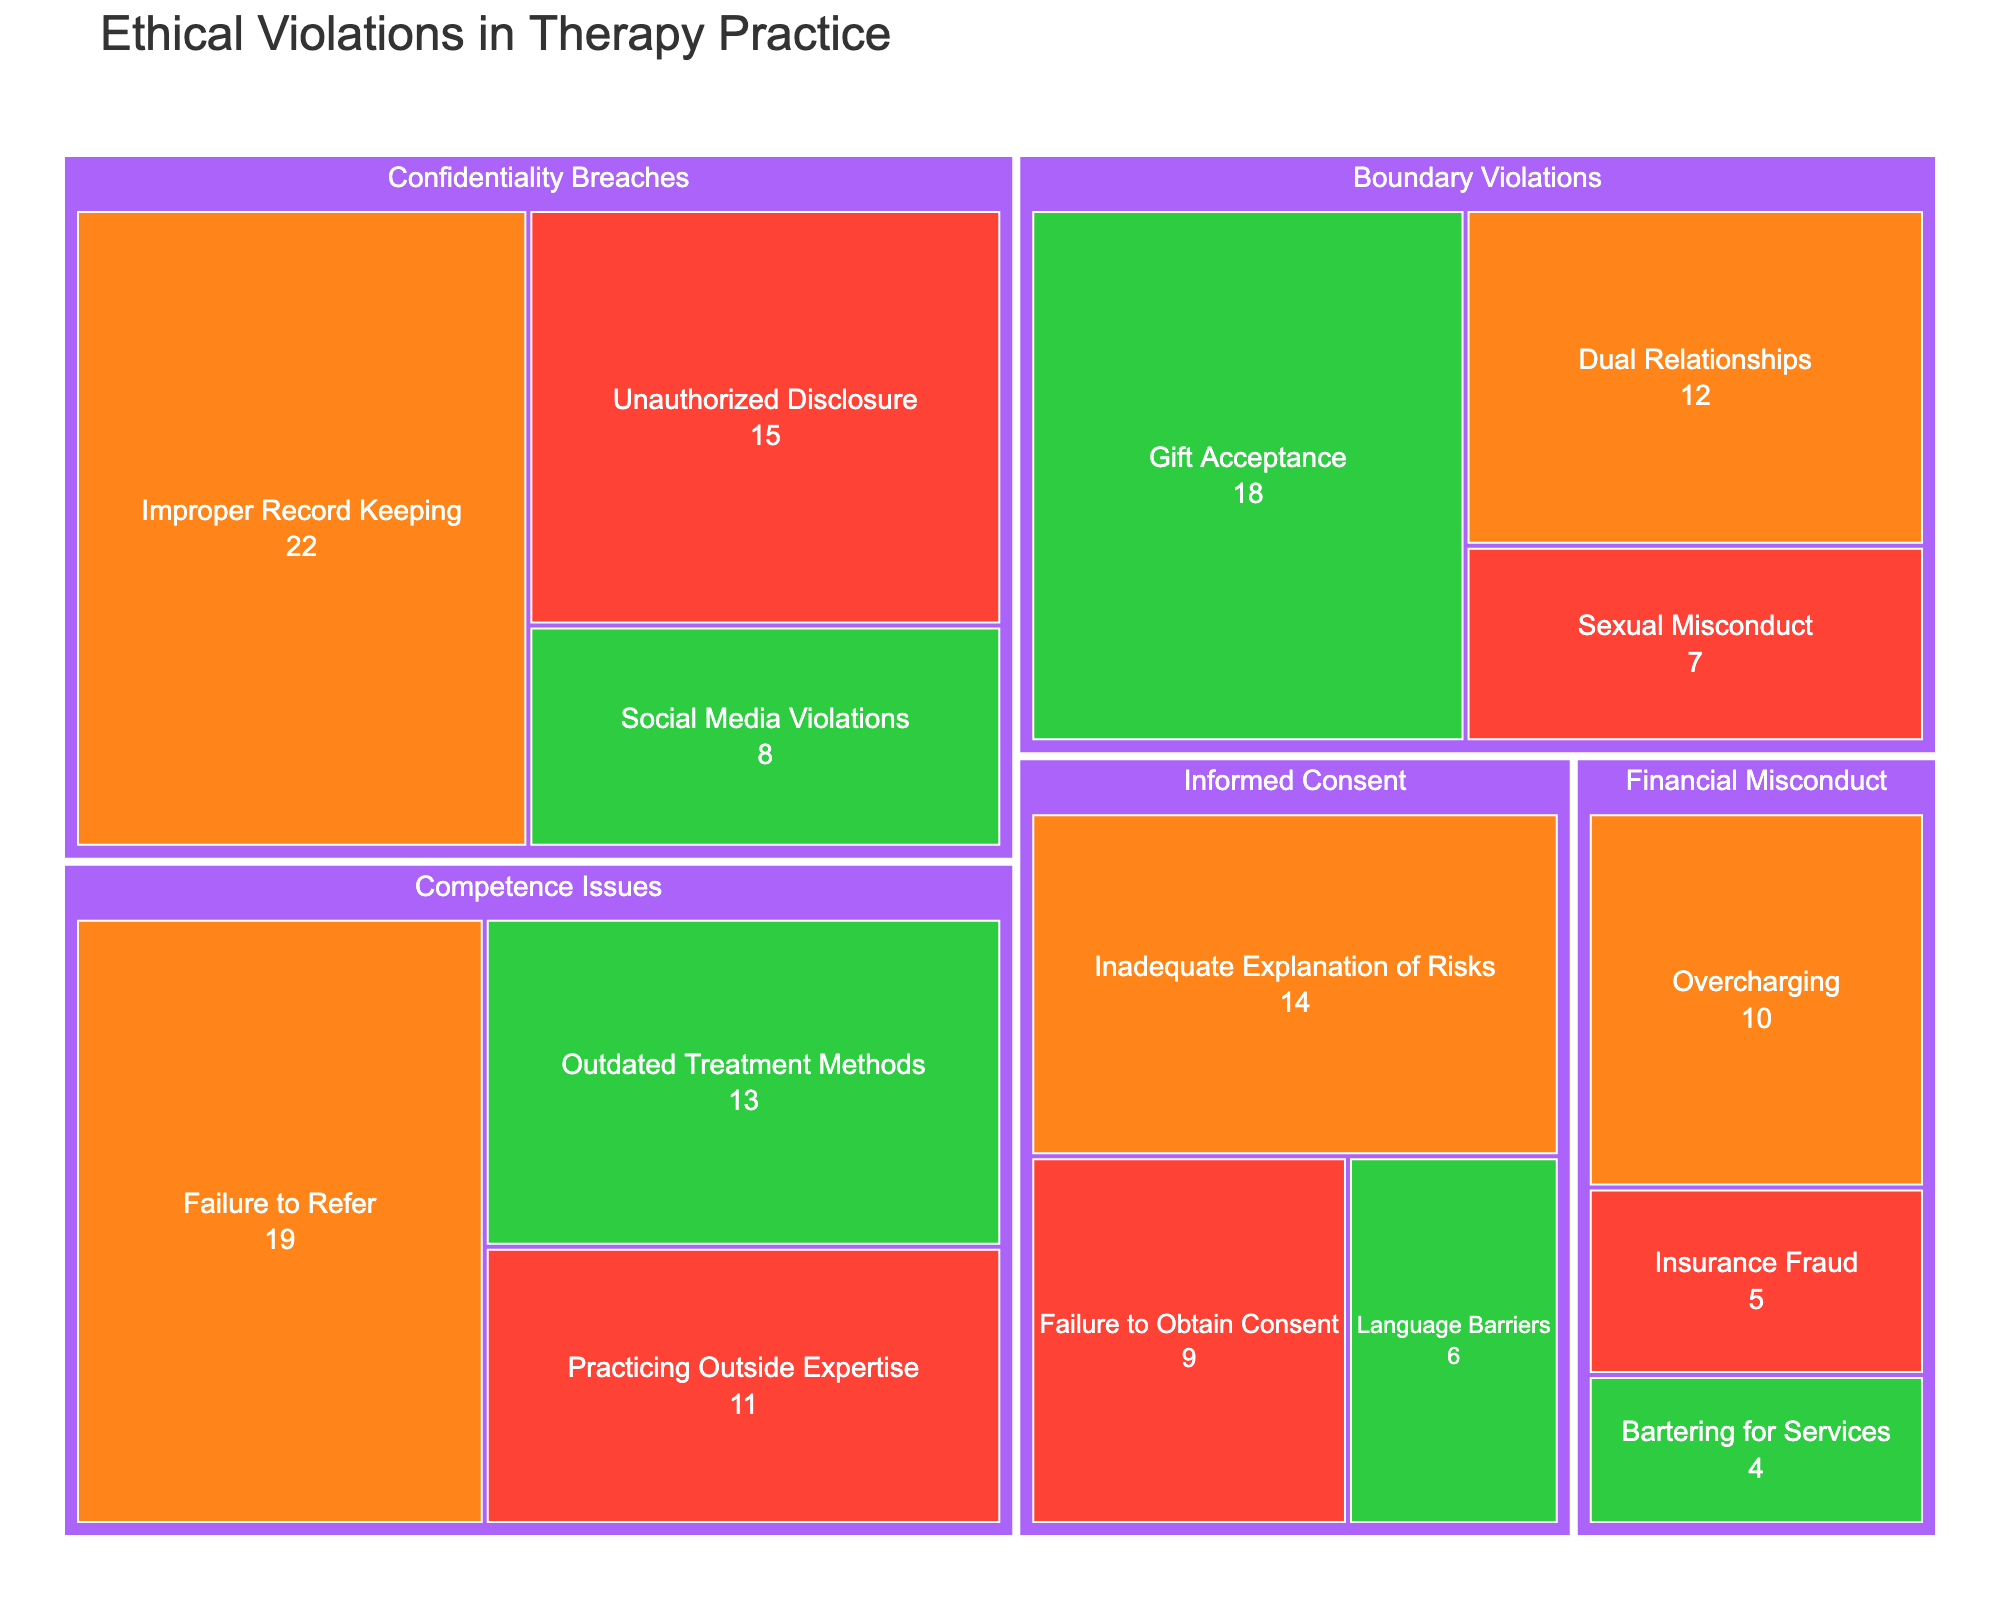What is the title of the figure? The title of the figure is usually prominently displayed at the top of the chart.
Answer: Ethical Violations in Therapy Practice Which subcategory under Boundary Violations has the highest frequency? By looking at the segments under "Boundary Violations," find the one with the largest area or highest value. This is "Gift Acceptance."
Answer: Gift Acceptance How many subcategories are under the Confidentiality Breaches category, and what are they? Count the subcategories within the "Confidentiality Breaches" section: "Unauthorized Disclosure," "Improper Record Keeping," and "Social Media Violations."
Answer: Three: Unauthorized Disclosure, Improper Record Keeping, Social Media Violations Compare the severity and frequency of dual relationships and gift acceptance violations. Which one is more frequent? Both "Dual Relationships" and "Gift Acceptance" are under "Boundary Violations." By comparing them, "Gift Acceptance" has a higher frequency (18) but a lower severity (Low).
Answer: Gift Acceptance What is the total frequency of all high-severity ethical violations? Sum the frequencies of all segments labeled as high severity: 15 (Unauthorized Disclosure) + 7 (Sexual Misconduct) + 9 (Failure to Obtain Consent) + 11 (Practicing Outside Expertise) + 5 (Insurance Fraud) = 47.
Answer: 47 Which category has the highest overall frequency and what is it? Sum the frequencies within each category and find the maximum value: Confidentiality Breaches (15+22+8), Boundary Violations (7+12+18), Informed Consent (9+14+6), Competence Issues (11+19+13), and Financial Misconduct (5+10+4). The highest is "Confidentiality Breaches" with a total of 45.
Answer: Confidentiality Breaches with 45 What is the severity of "Overcharging" in the category of Financial Misconduct? Locate the "Financial Misconduct" section and find the subcategory "Overcharging;" its severity is labeled "Medium."
Answer: Medium Between "Informed Consent" and "Competence Issues," which category has the least severe violations overall, considering both frequency and severity? Compare subcategories in "Informed Consent" and "Competence Issues" and note the severity and frequencies: "Informed Consent" has 9 (High), 14 (Medium), 6 (Low) resulting in 29 with varying severities; "Competence Issues" has 11 (High), 19 (Medium), 13 (Low) totaling 43 with varying severities. "Informed Consent" is less severe overall due to lower frequencies and mixed severities.
Answer: Informed Consent What is the most common severity of ethical violations depicted in the treemap? Count frequencies of high, medium, and low severity segments and compare: High (15+7+9+11+5 = 47), Medium (22+12+14+19+10 = 77), Low (8+18+6+13+4 = 49). Medium severity is most common.
Answer: Medium 